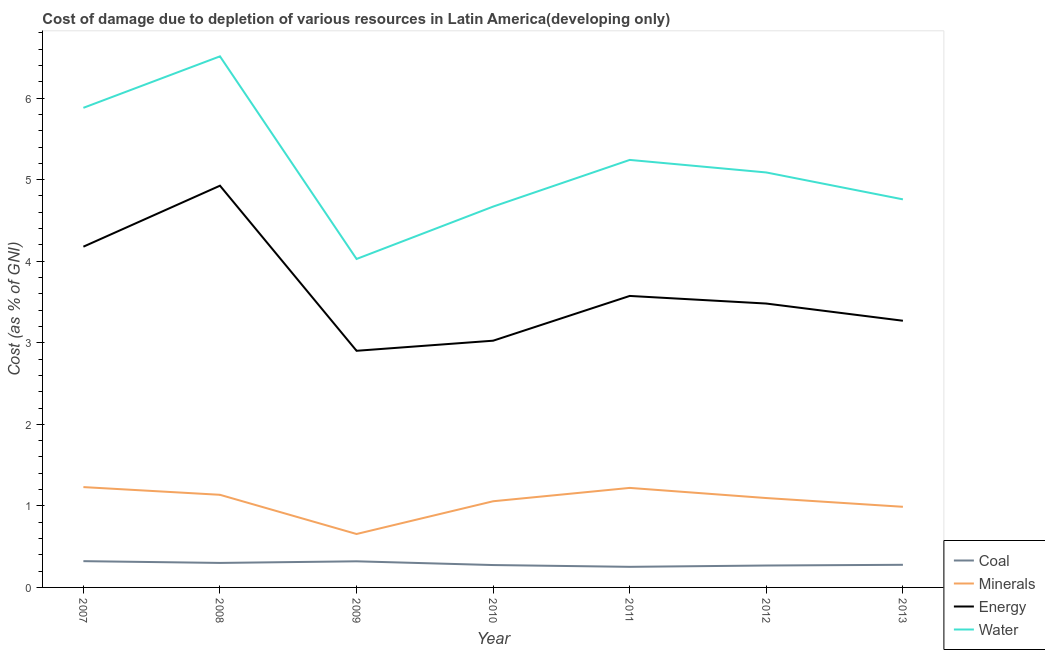Does the line corresponding to cost of damage due to depletion of energy intersect with the line corresponding to cost of damage due to depletion of minerals?
Your answer should be very brief. No. What is the cost of damage due to depletion of coal in 2012?
Your answer should be compact. 0.27. Across all years, what is the maximum cost of damage due to depletion of water?
Your answer should be very brief. 6.51. Across all years, what is the minimum cost of damage due to depletion of water?
Keep it short and to the point. 4.03. In which year was the cost of damage due to depletion of minerals minimum?
Make the answer very short. 2009. What is the total cost of damage due to depletion of minerals in the graph?
Provide a succinct answer. 7.38. What is the difference between the cost of damage due to depletion of energy in 2008 and that in 2011?
Give a very brief answer. 1.35. What is the difference between the cost of damage due to depletion of coal in 2011 and the cost of damage due to depletion of water in 2012?
Keep it short and to the point. -4.84. What is the average cost of damage due to depletion of water per year?
Offer a terse response. 5.17. In the year 2011, what is the difference between the cost of damage due to depletion of coal and cost of damage due to depletion of energy?
Your response must be concise. -3.32. What is the ratio of the cost of damage due to depletion of energy in 2010 to that in 2011?
Your answer should be compact. 0.85. Is the cost of damage due to depletion of coal in 2010 less than that in 2012?
Give a very brief answer. No. What is the difference between the highest and the second highest cost of damage due to depletion of water?
Ensure brevity in your answer.  0.63. What is the difference between the highest and the lowest cost of damage due to depletion of minerals?
Provide a succinct answer. 0.58. In how many years, is the cost of damage due to depletion of minerals greater than the average cost of damage due to depletion of minerals taken over all years?
Your answer should be compact. 5. Is the sum of the cost of damage due to depletion of water in 2011 and 2013 greater than the maximum cost of damage due to depletion of energy across all years?
Ensure brevity in your answer.  Yes. Does the cost of damage due to depletion of energy monotonically increase over the years?
Give a very brief answer. No. How many years are there in the graph?
Make the answer very short. 7. What is the difference between two consecutive major ticks on the Y-axis?
Offer a very short reply. 1. Where does the legend appear in the graph?
Offer a very short reply. Bottom right. How many legend labels are there?
Make the answer very short. 4. What is the title of the graph?
Offer a very short reply. Cost of damage due to depletion of various resources in Latin America(developing only) . Does "UNRWA" appear as one of the legend labels in the graph?
Your answer should be compact. No. What is the label or title of the X-axis?
Your answer should be very brief. Year. What is the label or title of the Y-axis?
Keep it short and to the point. Cost (as % of GNI). What is the Cost (as % of GNI) in Coal in 2007?
Offer a terse response. 0.32. What is the Cost (as % of GNI) of Minerals in 2007?
Provide a short and direct response. 1.23. What is the Cost (as % of GNI) in Energy in 2007?
Ensure brevity in your answer.  4.18. What is the Cost (as % of GNI) of Water in 2007?
Keep it short and to the point. 5.88. What is the Cost (as % of GNI) of Coal in 2008?
Make the answer very short. 0.3. What is the Cost (as % of GNI) of Minerals in 2008?
Offer a very short reply. 1.14. What is the Cost (as % of GNI) in Energy in 2008?
Your answer should be very brief. 4.93. What is the Cost (as % of GNI) in Water in 2008?
Make the answer very short. 6.51. What is the Cost (as % of GNI) in Coal in 2009?
Provide a short and direct response. 0.32. What is the Cost (as % of GNI) of Minerals in 2009?
Your response must be concise. 0.66. What is the Cost (as % of GNI) of Energy in 2009?
Provide a succinct answer. 2.9. What is the Cost (as % of GNI) in Water in 2009?
Offer a very short reply. 4.03. What is the Cost (as % of GNI) in Coal in 2010?
Your answer should be compact. 0.27. What is the Cost (as % of GNI) of Minerals in 2010?
Provide a succinct answer. 1.06. What is the Cost (as % of GNI) in Energy in 2010?
Provide a short and direct response. 3.03. What is the Cost (as % of GNI) of Water in 2010?
Give a very brief answer. 4.67. What is the Cost (as % of GNI) in Coal in 2011?
Give a very brief answer. 0.25. What is the Cost (as % of GNI) of Minerals in 2011?
Provide a succinct answer. 1.22. What is the Cost (as % of GNI) in Energy in 2011?
Provide a succinct answer. 3.57. What is the Cost (as % of GNI) in Water in 2011?
Your response must be concise. 5.24. What is the Cost (as % of GNI) in Coal in 2012?
Keep it short and to the point. 0.27. What is the Cost (as % of GNI) of Minerals in 2012?
Your answer should be very brief. 1.1. What is the Cost (as % of GNI) of Energy in 2012?
Provide a succinct answer. 3.48. What is the Cost (as % of GNI) in Water in 2012?
Offer a very short reply. 5.09. What is the Cost (as % of GNI) in Coal in 2013?
Your answer should be very brief. 0.28. What is the Cost (as % of GNI) in Minerals in 2013?
Make the answer very short. 0.99. What is the Cost (as % of GNI) of Energy in 2013?
Ensure brevity in your answer.  3.27. What is the Cost (as % of GNI) in Water in 2013?
Keep it short and to the point. 4.76. Across all years, what is the maximum Cost (as % of GNI) in Coal?
Keep it short and to the point. 0.32. Across all years, what is the maximum Cost (as % of GNI) of Minerals?
Ensure brevity in your answer.  1.23. Across all years, what is the maximum Cost (as % of GNI) of Energy?
Your response must be concise. 4.93. Across all years, what is the maximum Cost (as % of GNI) of Water?
Keep it short and to the point. 6.51. Across all years, what is the minimum Cost (as % of GNI) in Coal?
Give a very brief answer. 0.25. Across all years, what is the minimum Cost (as % of GNI) of Minerals?
Your response must be concise. 0.66. Across all years, what is the minimum Cost (as % of GNI) of Energy?
Make the answer very short. 2.9. Across all years, what is the minimum Cost (as % of GNI) in Water?
Offer a very short reply. 4.03. What is the total Cost (as % of GNI) in Coal in the graph?
Your answer should be very brief. 2.02. What is the total Cost (as % of GNI) of Minerals in the graph?
Your answer should be compact. 7.38. What is the total Cost (as % of GNI) in Energy in the graph?
Your response must be concise. 25.36. What is the total Cost (as % of GNI) in Water in the graph?
Provide a succinct answer. 36.18. What is the difference between the Cost (as % of GNI) in Coal in 2007 and that in 2008?
Offer a terse response. 0.02. What is the difference between the Cost (as % of GNI) of Minerals in 2007 and that in 2008?
Provide a short and direct response. 0.09. What is the difference between the Cost (as % of GNI) of Energy in 2007 and that in 2008?
Your response must be concise. -0.75. What is the difference between the Cost (as % of GNI) of Water in 2007 and that in 2008?
Offer a very short reply. -0.63. What is the difference between the Cost (as % of GNI) in Coal in 2007 and that in 2009?
Provide a short and direct response. 0. What is the difference between the Cost (as % of GNI) in Minerals in 2007 and that in 2009?
Provide a succinct answer. 0.58. What is the difference between the Cost (as % of GNI) of Energy in 2007 and that in 2009?
Make the answer very short. 1.28. What is the difference between the Cost (as % of GNI) in Water in 2007 and that in 2009?
Make the answer very short. 1.85. What is the difference between the Cost (as % of GNI) of Coal in 2007 and that in 2010?
Offer a terse response. 0.05. What is the difference between the Cost (as % of GNI) of Minerals in 2007 and that in 2010?
Keep it short and to the point. 0.17. What is the difference between the Cost (as % of GNI) of Energy in 2007 and that in 2010?
Provide a short and direct response. 1.15. What is the difference between the Cost (as % of GNI) in Water in 2007 and that in 2010?
Ensure brevity in your answer.  1.21. What is the difference between the Cost (as % of GNI) in Coal in 2007 and that in 2011?
Provide a short and direct response. 0.07. What is the difference between the Cost (as % of GNI) in Minerals in 2007 and that in 2011?
Your response must be concise. 0.01. What is the difference between the Cost (as % of GNI) in Energy in 2007 and that in 2011?
Offer a terse response. 0.6. What is the difference between the Cost (as % of GNI) in Water in 2007 and that in 2011?
Provide a short and direct response. 0.64. What is the difference between the Cost (as % of GNI) in Coal in 2007 and that in 2012?
Keep it short and to the point. 0.05. What is the difference between the Cost (as % of GNI) of Minerals in 2007 and that in 2012?
Provide a short and direct response. 0.13. What is the difference between the Cost (as % of GNI) in Energy in 2007 and that in 2012?
Give a very brief answer. 0.7. What is the difference between the Cost (as % of GNI) of Water in 2007 and that in 2012?
Offer a terse response. 0.79. What is the difference between the Cost (as % of GNI) of Coal in 2007 and that in 2013?
Your answer should be compact. 0.04. What is the difference between the Cost (as % of GNI) of Minerals in 2007 and that in 2013?
Your answer should be compact. 0.24. What is the difference between the Cost (as % of GNI) of Energy in 2007 and that in 2013?
Ensure brevity in your answer.  0.91. What is the difference between the Cost (as % of GNI) of Water in 2007 and that in 2013?
Make the answer very short. 1.12. What is the difference between the Cost (as % of GNI) of Coal in 2008 and that in 2009?
Make the answer very short. -0.02. What is the difference between the Cost (as % of GNI) of Minerals in 2008 and that in 2009?
Your answer should be very brief. 0.48. What is the difference between the Cost (as % of GNI) in Energy in 2008 and that in 2009?
Provide a succinct answer. 2.02. What is the difference between the Cost (as % of GNI) of Water in 2008 and that in 2009?
Your response must be concise. 2.48. What is the difference between the Cost (as % of GNI) of Coal in 2008 and that in 2010?
Keep it short and to the point. 0.03. What is the difference between the Cost (as % of GNI) of Minerals in 2008 and that in 2010?
Make the answer very short. 0.08. What is the difference between the Cost (as % of GNI) of Energy in 2008 and that in 2010?
Provide a short and direct response. 1.9. What is the difference between the Cost (as % of GNI) in Water in 2008 and that in 2010?
Offer a very short reply. 1.84. What is the difference between the Cost (as % of GNI) of Coal in 2008 and that in 2011?
Give a very brief answer. 0.05. What is the difference between the Cost (as % of GNI) of Minerals in 2008 and that in 2011?
Provide a succinct answer. -0.08. What is the difference between the Cost (as % of GNI) in Energy in 2008 and that in 2011?
Ensure brevity in your answer.  1.35. What is the difference between the Cost (as % of GNI) of Water in 2008 and that in 2011?
Keep it short and to the point. 1.27. What is the difference between the Cost (as % of GNI) in Coal in 2008 and that in 2012?
Offer a terse response. 0.03. What is the difference between the Cost (as % of GNI) of Minerals in 2008 and that in 2012?
Keep it short and to the point. 0.04. What is the difference between the Cost (as % of GNI) of Energy in 2008 and that in 2012?
Make the answer very short. 1.45. What is the difference between the Cost (as % of GNI) in Water in 2008 and that in 2012?
Your response must be concise. 1.42. What is the difference between the Cost (as % of GNI) in Coal in 2008 and that in 2013?
Provide a short and direct response. 0.02. What is the difference between the Cost (as % of GNI) in Minerals in 2008 and that in 2013?
Give a very brief answer. 0.15. What is the difference between the Cost (as % of GNI) of Energy in 2008 and that in 2013?
Offer a terse response. 1.66. What is the difference between the Cost (as % of GNI) of Water in 2008 and that in 2013?
Provide a short and direct response. 1.75. What is the difference between the Cost (as % of GNI) of Coal in 2009 and that in 2010?
Provide a short and direct response. 0.05. What is the difference between the Cost (as % of GNI) in Minerals in 2009 and that in 2010?
Provide a succinct answer. -0.4. What is the difference between the Cost (as % of GNI) in Energy in 2009 and that in 2010?
Ensure brevity in your answer.  -0.12. What is the difference between the Cost (as % of GNI) in Water in 2009 and that in 2010?
Your response must be concise. -0.64. What is the difference between the Cost (as % of GNI) of Coal in 2009 and that in 2011?
Provide a succinct answer. 0.07. What is the difference between the Cost (as % of GNI) in Minerals in 2009 and that in 2011?
Provide a short and direct response. -0.57. What is the difference between the Cost (as % of GNI) in Energy in 2009 and that in 2011?
Your answer should be very brief. -0.67. What is the difference between the Cost (as % of GNI) in Water in 2009 and that in 2011?
Make the answer very short. -1.21. What is the difference between the Cost (as % of GNI) in Coal in 2009 and that in 2012?
Provide a succinct answer. 0.05. What is the difference between the Cost (as % of GNI) of Minerals in 2009 and that in 2012?
Keep it short and to the point. -0.44. What is the difference between the Cost (as % of GNI) of Energy in 2009 and that in 2012?
Give a very brief answer. -0.58. What is the difference between the Cost (as % of GNI) of Water in 2009 and that in 2012?
Keep it short and to the point. -1.06. What is the difference between the Cost (as % of GNI) in Coal in 2009 and that in 2013?
Make the answer very short. 0.04. What is the difference between the Cost (as % of GNI) in Minerals in 2009 and that in 2013?
Keep it short and to the point. -0.33. What is the difference between the Cost (as % of GNI) in Energy in 2009 and that in 2013?
Give a very brief answer. -0.37. What is the difference between the Cost (as % of GNI) in Water in 2009 and that in 2013?
Ensure brevity in your answer.  -0.73. What is the difference between the Cost (as % of GNI) in Coal in 2010 and that in 2011?
Ensure brevity in your answer.  0.02. What is the difference between the Cost (as % of GNI) in Minerals in 2010 and that in 2011?
Make the answer very short. -0.16. What is the difference between the Cost (as % of GNI) of Energy in 2010 and that in 2011?
Provide a succinct answer. -0.55. What is the difference between the Cost (as % of GNI) in Water in 2010 and that in 2011?
Provide a short and direct response. -0.57. What is the difference between the Cost (as % of GNI) of Coal in 2010 and that in 2012?
Ensure brevity in your answer.  0.01. What is the difference between the Cost (as % of GNI) in Minerals in 2010 and that in 2012?
Offer a terse response. -0.04. What is the difference between the Cost (as % of GNI) in Energy in 2010 and that in 2012?
Your answer should be very brief. -0.46. What is the difference between the Cost (as % of GNI) of Water in 2010 and that in 2012?
Your answer should be very brief. -0.42. What is the difference between the Cost (as % of GNI) in Coal in 2010 and that in 2013?
Your answer should be compact. -0. What is the difference between the Cost (as % of GNI) in Minerals in 2010 and that in 2013?
Provide a short and direct response. 0.07. What is the difference between the Cost (as % of GNI) of Energy in 2010 and that in 2013?
Offer a very short reply. -0.24. What is the difference between the Cost (as % of GNI) of Water in 2010 and that in 2013?
Offer a very short reply. -0.09. What is the difference between the Cost (as % of GNI) in Coal in 2011 and that in 2012?
Your answer should be compact. -0.02. What is the difference between the Cost (as % of GNI) of Minerals in 2011 and that in 2012?
Offer a very short reply. 0.12. What is the difference between the Cost (as % of GNI) of Energy in 2011 and that in 2012?
Provide a short and direct response. 0.09. What is the difference between the Cost (as % of GNI) of Water in 2011 and that in 2012?
Offer a very short reply. 0.15. What is the difference between the Cost (as % of GNI) in Coal in 2011 and that in 2013?
Your answer should be compact. -0.03. What is the difference between the Cost (as % of GNI) in Minerals in 2011 and that in 2013?
Your response must be concise. 0.23. What is the difference between the Cost (as % of GNI) in Energy in 2011 and that in 2013?
Offer a terse response. 0.3. What is the difference between the Cost (as % of GNI) in Water in 2011 and that in 2013?
Provide a short and direct response. 0.48. What is the difference between the Cost (as % of GNI) of Coal in 2012 and that in 2013?
Offer a very short reply. -0.01. What is the difference between the Cost (as % of GNI) of Minerals in 2012 and that in 2013?
Your answer should be compact. 0.11. What is the difference between the Cost (as % of GNI) of Energy in 2012 and that in 2013?
Give a very brief answer. 0.21. What is the difference between the Cost (as % of GNI) of Water in 2012 and that in 2013?
Give a very brief answer. 0.33. What is the difference between the Cost (as % of GNI) in Coal in 2007 and the Cost (as % of GNI) in Minerals in 2008?
Make the answer very short. -0.81. What is the difference between the Cost (as % of GNI) of Coal in 2007 and the Cost (as % of GNI) of Energy in 2008?
Offer a very short reply. -4.6. What is the difference between the Cost (as % of GNI) of Coal in 2007 and the Cost (as % of GNI) of Water in 2008?
Offer a terse response. -6.19. What is the difference between the Cost (as % of GNI) of Minerals in 2007 and the Cost (as % of GNI) of Energy in 2008?
Offer a very short reply. -3.7. What is the difference between the Cost (as % of GNI) of Minerals in 2007 and the Cost (as % of GNI) of Water in 2008?
Your answer should be compact. -5.28. What is the difference between the Cost (as % of GNI) of Energy in 2007 and the Cost (as % of GNI) of Water in 2008?
Offer a very short reply. -2.33. What is the difference between the Cost (as % of GNI) in Coal in 2007 and the Cost (as % of GNI) in Minerals in 2009?
Your answer should be very brief. -0.33. What is the difference between the Cost (as % of GNI) of Coal in 2007 and the Cost (as % of GNI) of Energy in 2009?
Keep it short and to the point. -2.58. What is the difference between the Cost (as % of GNI) in Coal in 2007 and the Cost (as % of GNI) in Water in 2009?
Your response must be concise. -3.71. What is the difference between the Cost (as % of GNI) of Minerals in 2007 and the Cost (as % of GNI) of Energy in 2009?
Offer a terse response. -1.67. What is the difference between the Cost (as % of GNI) in Minerals in 2007 and the Cost (as % of GNI) in Water in 2009?
Your answer should be very brief. -2.8. What is the difference between the Cost (as % of GNI) of Energy in 2007 and the Cost (as % of GNI) of Water in 2009?
Provide a succinct answer. 0.15. What is the difference between the Cost (as % of GNI) of Coal in 2007 and the Cost (as % of GNI) of Minerals in 2010?
Give a very brief answer. -0.73. What is the difference between the Cost (as % of GNI) of Coal in 2007 and the Cost (as % of GNI) of Energy in 2010?
Your answer should be very brief. -2.7. What is the difference between the Cost (as % of GNI) of Coal in 2007 and the Cost (as % of GNI) of Water in 2010?
Provide a succinct answer. -4.35. What is the difference between the Cost (as % of GNI) in Minerals in 2007 and the Cost (as % of GNI) in Energy in 2010?
Provide a succinct answer. -1.8. What is the difference between the Cost (as % of GNI) in Minerals in 2007 and the Cost (as % of GNI) in Water in 2010?
Provide a short and direct response. -3.44. What is the difference between the Cost (as % of GNI) of Energy in 2007 and the Cost (as % of GNI) of Water in 2010?
Your answer should be compact. -0.49. What is the difference between the Cost (as % of GNI) of Coal in 2007 and the Cost (as % of GNI) of Minerals in 2011?
Make the answer very short. -0.9. What is the difference between the Cost (as % of GNI) of Coal in 2007 and the Cost (as % of GNI) of Energy in 2011?
Keep it short and to the point. -3.25. What is the difference between the Cost (as % of GNI) in Coal in 2007 and the Cost (as % of GNI) in Water in 2011?
Offer a terse response. -4.92. What is the difference between the Cost (as % of GNI) in Minerals in 2007 and the Cost (as % of GNI) in Energy in 2011?
Your response must be concise. -2.34. What is the difference between the Cost (as % of GNI) of Minerals in 2007 and the Cost (as % of GNI) of Water in 2011?
Offer a terse response. -4.01. What is the difference between the Cost (as % of GNI) in Energy in 2007 and the Cost (as % of GNI) in Water in 2011?
Make the answer very short. -1.06. What is the difference between the Cost (as % of GNI) of Coal in 2007 and the Cost (as % of GNI) of Minerals in 2012?
Give a very brief answer. -0.77. What is the difference between the Cost (as % of GNI) of Coal in 2007 and the Cost (as % of GNI) of Energy in 2012?
Offer a very short reply. -3.16. What is the difference between the Cost (as % of GNI) in Coal in 2007 and the Cost (as % of GNI) in Water in 2012?
Provide a succinct answer. -4.77. What is the difference between the Cost (as % of GNI) in Minerals in 2007 and the Cost (as % of GNI) in Energy in 2012?
Offer a very short reply. -2.25. What is the difference between the Cost (as % of GNI) in Minerals in 2007 and the Cost (as % of GNI) in Water in 2012?
Ensure brevity in your answer.  -3.86. What is the difference between the Cost (as % of GNI) of Energy in 2007 and the Cost (as % of GNI) of Water in 2012?
Offer a terse response. -0.91. What is the difference between the Cost (as % of GNI) in Coal in 2007 and the Cost (as % of GNI) in Minerals in 2013?
Ensure brevity in your answer.  -0.67. What is the difference between the Cost (as % of GNI) in Coal in 2007 and the Cost (as % of GNI) in Energy in 2013?
Provide a succinct answer. -2.95. What is the difference between the Cost (as % of GNI) of Coal in 2007 and the Cost (as % of GNI) of Water in 2013?
Ensure brevity in your answer.  -4.44. What is the difference between the Cost (as % of GNI) in Minerals in 2007 and the Cost (as % of GNI) in Energy in 2013?
Provide a succinct answer. -2.04. What is the difference between the Cost (as % of GNI) in Minerals in 2007 and the Cost (as % of GNI) in Water in 2013?
Your answer should be compact. -3.53. What is the difference between the Cost (as % of GNI) in Energy in 2007 and the Cost (as % of GNI) in Water in 2013?
Provide a succinct answer. -0.58. What is the difference between the Cost (as % of GNI) in Coal in 2008 and the Cost (as % of GNI) in Minerals in 2009?
Ensure brevity in your answer.  -0.35. What is the difference between the Cost (as % of GNI) of Coal in 2008 and the Cost (as % of GNI) of Energy in 2009?
Provide a succinct answer. -2.6. What is the difference between the Cost (as % of GNI) of Coal in 2008 and the Cost (as % of GNI) of Water in 2009?
Make the answer very short. -3.73. What is the difference between the Cost (as % of GNI) of Minerals in 2008 and the Cost (as % of GNI) of Energy in 2009?
Ensure brevity in your answer.  -1.77. What is the difference between the Cost (as % of GNI) of Minerals in 2008 and the Cost (as % of GNI) of Water in 2009?
Provide a short and direct response. -2.89. What is the difference between the Cost (as % of GNI) in Energy in 2008 and the Cost (as % of GNI) in Water in 2009?
Your answer should be very brief. 0.9. What is the difference between the Cost (as % of GNI) in Coal in 2008 and the Cost (as % of GNI) in Minerals in 2010?
Provide a short and direct response. -0.76. What is the difference between the Cost (as % of GNI) in Coal in 2008 and the Cost (as % of GNI) in Energy in 2010?
Ensure brevity in your answer.  -2.73. What is the difference between the Cost (as % of GNI) in Coal in 2008 and the Cost (as % of GNI) in Water in 2010?
Offer a very short reply. -4.37. What is the difference between the Cost (as % of GNI) in Minerals in 2008 and the Cost (as % of GNI) in Energy in 2010?
Make the answer very short. -1.89. What is the difference between the Cost (as % of GNI) in Minerals in 2008 and the Cost (as % of GNI) in Water in 2010?
Offer a terse response. -3.53. What is the difference between the Cost (as % of GNI) of Energy in 2008 and the Cost (as % of GNI) of Water in 2010?
Offer a terse response. 0.26. What is the difference between the Cost (as % of GNI) of Coal in 2008 and the Cost (as % of GNI) of Minerals in 2011?
Give a very brief answer. -0.92. What is the difference between the Cost (as % of GNI) of Coal in 2008 and the Cost (as % of GNI) of Energy in 2011?
Keep it short and to the point. -3.27. What is the difference between the Cost (as % of GNI) of Coal in 2008 and the Cost (as % of GNI) of Water in 2011?
Give a very brief answer. -4.94. What is the difference between the Cost (as % of GNI) of Minerals in 2008 and the Cost (as % of GNI) of Energy in 2011?
Ensure brevity in your answer.  -2.44. What is the difference between the Cost (as % of GNI) in Minerals in 2008 and the Cost (as % of GNI) in Water in 2011?
Provide a short and direct response. -4.11. What is the difference between the Cost (as % of GNI) of Energy in 2008 and the Cost (as % of GNI) of Water in 2011?
Offer a terse response. -0.32. What is the difference between the Cost (as % of GNI) of Coal in 2008 and the Cost (as % of GNI) of Minerals in 2012?
Your response must be concise. -0.8. What is the difference between the Cost (as % of GNI) of Coal in 2008 and the Cost (as % of GNI) of Energy in 2012?
Your response must be concise. -3.18. What is the difference between the Cost (as % of GNI) of Coal in 2008 and the Cost (as % of GNI) of Water in 2012?
Provide a short and direct response. -4.79. What is the difference between the Cost (as % of GNI) in Minerals in 2008 and the Cost (as % of GNI) in Energy in 2012?
Offer a very short reply. -2.35. What is the difference between the Cost (as % of GNI) of Minerals in 2008 and the Cost (as % of GNI) of Water in 2012?
Keep it short and to the point. -3.95. What is the difference between the Cost (as % of GNI) in Energy in 2008 and the Cost (as % of GNI) in Water in 2012?
Offer a terse response. -0.16. What is the difference between the Cost (as % of GNI) of Coal in 2008 and the Cost (as % of GNI) of Minerals in 2013?
Offer a terse response. -0.69. What is the difference between the Cost (as % of GNI) of Coal in 2008 and the Cost (as % of GNI) of Energy in 2013?
Offer a terse response. -2.97. What is the difference between the Cost (as % of GNI) of Coal in 2008 and the Cost (as % of GNI) of Water in 2013?
Give a very brief answer. -4.46. What is the difference between the Cost (as % of GNI) of Minerals in 2008 and the Cost (as % of GNI) of Energy in 2013?
Keep it short and to the point. -2.13. What is the difference between the Cost (as % of GNI) in Minerals in 2008 and the Cost (as % of GNI) in Water in 2013?
Offer a very short reply. -3.62. What is the difference between the Cost (as % of GNI) in Energy in 2008 and the Cost (as % of GNI) in Water in 2013?
Offer a terse response. 0.17. What is the difference between the Cost (as % of GNI) of Coal in 2009 and the Cost (as % of GNI) of Minerals in 2010?
Keep it short and to the point. -0.74. What is the difference between the Cost (as % of GNI) of Coal in 2009 and the Cost (as % of GNI) of Energy in 2010?
Give a very brief answer. -2.71. What is the difference between the Cost (as % of GNI) of Coal in 2009 and the Cost (as % of GNI) of Water in 2010?
Your answer should be compact. -4.35. What is the difference between the Cost (as % of GNI) in Minerals in 2009 and the Cost (as % of GNI) in Energy in 2010?
Offer a terse response. -2.37. What is the difference between the Cost (as % of GNI) in Minerals in 2009 and the Cost (as % of GNI) in Water in 2010?
Give a very brief answer. -4.01. What is the difference between the Cost (as % of GNI) of Energy in 2009 and the Cost (as % of GNI) of Water in 2010?
Make the answer very short. -1.77. What is the difference between the Cost (as % of GNI) of Coal in 2009 and the Cost (as % of GNI) of Minerals in 2011?
Give a very brief answer. -0.9. What is the difference between the Cost (as % of GNI) in Coal in 2009 and the Cost (as % of GNI) in Energy in 2011?
Provide a short and direct response. -3.25. What is the difference between the Cost (as % of GNI) in Coal in 2009 and the Cost (as % of GNI) in Water in 2011?
Provide a succinct answer. -4.92. What is the difference between the Cost (as % of GNI) of Minerals in 2009 and the Cost (as % of GNI) of Energy in 2011?
Provide a succinct answer. -2.92. What is the difference between the Cost (as % of GNI) in Minerals in 2009 and the Cost (as % of GNI) in Water in 2011?
Keep it short and to the point. -4.59. What is the difference between the Cost (as % of GNI) of Energy in 2009 and the Cost (as % of GNI) of Water in 2011?
Your answer should be compact. -2.34. What is the difference between the Cost (as % of GNI) in Coal in 2009 and the Cost (as % of GNI) in Minerals in 2012?
Offer a very short reply. -0.78. What is the difference between the Cost (as % of GNI) of Coal in 2009 and the Cost (as % of GNI) of Energy in 2012?
Make the answer very short. -3.16. What is the difference between the Cost (as % of GNI) in Coal in 2009 and the Cost (as % of GNI) in Water in 2012?
Your answer should be very brief. -4.77. What is the difference between the Cost (as % of GNI) of Minerals in 2009 and the Cost (as % of GNI) of Energy in 2012?
Offer a very short reply. -2.83. What is the difference between the Cost (as % of GNI) of Minerals in 2009 and the Cost (as % of GNI) of Water in 2012?
Make the answer very short. -4.43. What is the difference between the Cost (as % of GNI) of Energy in 2009 and the Cost (as % of GNI) of Water in 2012?
Offer a terse response. -2.19. What is the difference between the Cost (as % of GNI) in Coal in 2009 and the Cost (as % of GNI) in Minerals in 2013?
Provide a short and direct response. -0.67. What is the difference between the Cost (as % of GNI) of Coal in 2009 and the Cost (as % of GNI) of Energy in 2013?
Offer a very short reply. -2.95. What is the difference between the Cost (as % of GNI) of Coal in 2009 and the Cost (as % of GNI) of Water in 2013?
Keep it short and to the point. -4.44. What is the difference between the Cost (as % of GNI) in Minerals in 2009 and the Cost (as % of GNI) in Energy in 2013?
Keep it short and to the point. -2.62. What is the difference between the Cost (as % of GNI) of Minerals in 2009 and the Cost (as % of GNI) of Water in 2013?
Ensure brevity in your answer.  -4.1. What is the difference between the Cost (as % of GNI) of Energy in 2009 and the Cost (as % of GNI) of Water in 2013?
Your answer should be compact. -1.86. What is the difference between the Cost (as % of GNI) of Coal in 2010 and the Cost (as % of GNI) of Minerals in 2011?
Offer a terse response. -0.95. What is the difference between the Cost (as % of GNI) in Coal in 2010 and the Cost (as % of GNI) in Energy in 2011?
Your answer should be very brief. -3.3. What is the difference between the Cost (as % of GNI) in Coal in 2010 and the Cost (as % of GNI) in Water in 2011?
Your response must be concise. -4.97. What is the difference between the Cost (as % of GNI) in Minerals in 2010 and the Cost (as % of GNI) in Energy in 2011?
Provide a short and direct response. -2.52. What is the difference between the Cost (as % of GNI) in Minerals in 2010 and the Cost (as % of GNI) in Water in 2011?
Provide a short and direct response. -4.19. What is the difference between the Cost (as % of GNI) of Energy in 2010 and the Cost (as % of GNI) of Water in 2011?
Make the answer very short. -2.22. What is the difference between the Cost (as % of GNI) in Coal in 2010 and the Cost (as % of GNI) in Minerals in 2012?
Give a very brief answer. -0.82. What is the difference between the Cost (as % of GNI) of Coal in 2010 and the Cost (as % of GNI) of Energy in 2012?
Ensure brevity in your answer.  -3.21. What is the difference between the Cost (as % of GNI) of Coal in 2010 and the Cost (as % of GNI) of Water in 2012?
Provide a short and direct response. -4.81. What is the difference between the Cost (as % of GNI) in Minerals in 2010 and the Cost (as % of GNI) in Energy in 2012?
Give a very brief answer. -2.42. What is the difference between the Cost (as % of GNI) in Minerals in 2010 and the Cost (as % of GNI) in Water in 2012?
Your response must be concise. -4.03. What is the difference between the Cost (as % of GNI) in Energy in 2010 and the Cost (as % of GNI) in Water in 2012?
Give a very brief answer. -2.06. What is the difference between the Cost (as % of GNI) of Coal in 2010 and the Cost (as % of GNI) of Minerals in 2013?
Ensure brevity in your answer.  -0.71. What is the difference between the Cost (as % of GNI) in Coal in 2010 and the Cost (as % of GNI) in Energy in 2013?
Give a very brief answer. -3. What is the difference between the Cost (as % of GNI) of Coal in 2010 and the Cost (as % of GNI) of Water in 2013?
Your response must be concise. -4.48. What is the difference between the Cost (as % of GNI) of Minerals in 2010 and the Cost (as % of GNI) of Energy in 2013?
Offer a terse response. -2.21. What is the difference between the Cost (as % of GNI) in Minerals in 2010 and the Cost (as % of GNI) in Water in 2013?
Make the answer very short. -3.7. What is the difference between the Cost (as % of GNI) of Energy in 2010 and the Cost (as % of GNI) of Water in 2013?
Offer a very short reply. -1.73. What is the difference between the Cost (as % of GNI) in Coal in 2011 and the Cost (as % of GNI) in Minerals in 2012?
Offer a very short reply. -0.84. What is the difference between the Cost (as % of GNI) of Coal in 2011 and the Cost (as % of GNI) of Energy in 2012?
Give a very brief answer. -3.23. What is the difference between the Cost (as % of GNI) of Coal in 2011 and the Cost (as % of GNI) of Water in 2012?
Your response must be concise. -4.84. What is the difference between the Cost (as % of GNI) in Minerals in 2011 and the Cost (as % of GNI) in Energy in 2012?
Keep it short and to the point. -2.26. What is the difference between the Cost (as % of GNI) in Minerals in 2011 and the Cost (as % of GNI) in Water in 2012?
Make the answer very short. -3.87. What is the difference between the Cost (as % of GNI) of Energy in 2011 and the Cost (as % of GNI) of Water in 2012?
Make the answer very short. -1.51. What is the difference between the Cost (as % of GNI) of Coal in 2011 and the Cost (as % of GNI) of Minerals in 2013?
Offer a terse response. -0.74. What is the difference between the Cost (as % of GNI) in Coal in 2011 and the Cost (as % of GNI) in Energy in 2013?
Ensure brevity in your answer.  -3.02. What is the difference between the Cost (as % of GNI) of Coal in 2011 and the Cost (as % of GNI) of Water in 2013?
Your response must be concise. -4.51. What is the difference between the Cost (as % of GNI) of Minerals in 2011 and the Cost (as % of GNI) of Energy in 2013?
Provide a succinct answer. -2.05. What is the difference between the Cost (as % of GNI) of Minerals in 2011 and the Cost (as % of GNI) of Water in 2013?
Give a very brief answer. -3.54. What is the difference between the Cost (as % of GNI) in Energy in 2011 and the Cost (as % of GNI) in Water in 2013?
Your answer should be very brief. -1.18. What is the difference between the Cost (as % of GNI) of Coal in 2012 and the Cost (as % of GNI) of Minerals in 2013?
Provide a short and direct response. -0.72. What is the difference between the Cost (as % of GNI) in Coal in 2012 and the Cost (as % of GNI) in Energy in 2013?
Your answer should be compact. -3. What is the difference between the Cost (as % of GNI) in Coal in 2012 and the Cost (as % of GNI) in Water in 2013?
Provide a succinct answer. -4.49. What is the difference between the Cost (as % of GNI) in Minerals in 2012 and the Cost (as % of GNI) in Energy in 2013?
Give a very brief answer. -2.17. What is the difference between the Cost (as % of GNI) in Minerals in 2012 and the Cost (as % of GNI) in Water in 2013?
Give a very brief answer. -3.66. What is the difference between the Cost (as % of GNI) in Energy in 2012 and the Cost (as % of GNI) in Water in 2013?
Offer a terse response. -1.28. What is the average Cost (as % of GNI) of Coal per year?
Your answer should be compact. 0.29. What is the average Cost (as % of GNI) in Minerals per year?
Your answer should be compact. 1.05. What is the average Cost (as % of GNI) in Energy per year?
Provide a succinct answer. 3.62. What is the average Cost (as % of GNI) of Water per year?
Offer a terse response. 5.17. In the year 2007, what is the difference between the Cost (as % of GNI) of Coal and Cost (as % of GNI) of Minerals?
Provide a succinct answer. -0.91. In the year 2007, what is the difference between the Cost (as % of GNI) in Coal and Cost (as % of GNI) in Energy?
Provide a succinct answer. -3.86. In the year 2007, what is the difference between the Cost (as % of GNI) in Coal and Cost (as % of GNI) in Water?
Give a very brief answer. -5.56. In the year 2007, what is the difference between the Cost (as % of GNI) in Minerals and Cost (as % of GNI) in Energy?
Offer a terse response. -2.95. In the year 2007, what is the difference between the Cost (as % of GNI) in Minerals and Cost (as % of GNI) in Water?
Provide a short and direct response. -4.65. In the year 2007, what is the difference between the Cost (as % of GNI) of Energy and Cost (as % of GNI) of Water?
Provide a succinct answer. -1.7. In the year 2008, what is the difference between the Cost (as % of GNI) of Coal and Cost (as % of GNI) of Minerals?
Your response must be concise. -0.84. In the year 2008, what is the difference between the Cost (as % of GNI) in Coal and Cost (as % of GNI) in Energy?
Make the answer very short. -4.63. In the year 2008, what is the difference between the Cost (as % of GNI) in Coal and Cost (as % of GNI) in Water?
Your answer should be very brief. -6.21. In the year 2008, what is the difference between the Cost (as % of GNI) in Minerals and Cost (as % of GNI) in Energy?
Ensure brevity in your answer.  -3.79. In the year 2008, what is the difference between the Cost (as % of GNI) in Minerals and Cost (as % of GNI) in Water?
Keep it short and to the point. -5.38. In the year 2008, what is the difference between the Cost (as % of GNI) of Energy and Cost (as % of GNI) of Water?
Your answer should be compact. -1.59. In the year 2009, what is the difference between the Cost (as % of GNI) in Coal and Cost (as % of GNI) in Minerals?
Give a very brief answer. -0.33. In the year 2009, what is the difference between the Cost (as % of GNI) in Coal and Cost (as % of GNI) in Energy?
Your answer should be compact. -2.58. In the year 2009, what is the difference between the Cost (as % of GNI) of Coal and Cost (as % of GNI) of Water?
Your answer should be very brief. -3.71. In the year 2009, what is the difference between the Cost (as % of GNI) in Minerals and Cost (as % of GNI) in Energy?
Your answer should be very brief. -2.25. In the year 2009, what is the difference between the Cost (as % of GNI) of Minerals and Cost (as % of GNI) of Water?
Give a very brief answer. -3.37. In the year 2009, what is the difference between the Cost (as % of GNI) in Energy and Cost (as % of GNI) in Water?
Give a very brief answer. -1.13. In the year 2010, what is the difference between the Cost (as % of GNI) in Coal and Cost (as % of GNI) in Minerals?
Ensure brevity in your answer.  -0.78. In the year 2010, what is the difference between the Cost (as % of GNI) in Coal and Cost (as % of GNI) in Energy?
Provide a succinct answer. -2.75. In the year 2010, what is the difference between the Cost (as % of GNI) in Coal and Cost (as % of GNI) in Water?
Your answer should be compact. -4.4. In the year 2010, what is the difference between the Cost (as % of GNI) in Minerals and Cost (as % of GNI) in Energy?
Offer a terse response. -1.97. In the year 2010, what is the difference between the Cost (as % of GNI) of Minerals and Cost (as % of GNI) of Water?
Your answer should be very brief. -3.61. In the year 2010, what is the difference between the Cost (as % of GNI) of Energy and Cost (as % of GNI) of Water?
Offer a very short reply. -1.64. In the year 2011, what is the difference between the Cost (as % of GNI) in Coal and Cost (as % of GNI) in Minerals?
Give a very brief answer. -0.97. In the year 2011, what is the difference between the Cost (as % of GNI) of Coal and Cost (as % of GNI) of Energy?
Your answer should be very brief. -3.32. In the year 2011, what is the difference between the Cost (as % of GNI) in Coal and Cost (as % of GNI) in Water?
Your answer should be compact. -4.99. In the year 2011, what is the difference between the Cost (as % of GNI) in Minerals and Cost (as % of GNI) in Energy?
Provide a succinct answer. -2.35. In the year 2011, what is the difference between the Cost (as % of GNI) of Minerals and Cost (as % of GNI) of Water?
Your answer should be compact. -4.02. In the year 2011, what is the difference between the Cost (as % of GNI) of Energy and Cost (as % of GNI) of Water?
Provide a short and direct response. -1.67. In the year 2012, what is the difference between the Cost (as % of GNI) of Coal and Cost (as % of GNI) of Minerals?
Your answer should be very brief. -0.83. In the year 2012, what is the difference between the Cost (as % of GNI) of Coal and Cost (as % of GNI) of Energy?
Your answer should be compact. -3.21. In the year 2012, what is the difference between the Cost (as % of GNI) in Coal and Cost (as % of GNI) in Water?
Offer a terse response. -4.82. In the year 2012, what is the difference between the Cost (as % of GNI) of Minerals and Cost (as % of GNI) of Energy?
Provide a succinct answer. -2.38. In the year 2012, what is the difference between the Cost (as % of GNI) in Minerals and Cost (as % of GNI) in Water?
Your answer should be very brief. -3.99. In the year 2012, what is the difference between the Cost (as % of GNI) of Energy and Cost (as % of GNI) of Water?
Offer a very short reply. -1.61. In the year 2013, what is the difference between the Cost (as % of GNI) of Coal and Cost (as % of GNI) of Minerals?
Provide a short and direct response. -0.71. In the year 2013, what is the difference between the Cost (as % of GNI) in Coal and Cost (as % of GNI) in Energy?
Offer a terse response. -2.99. In the year 2013, what is the difference between the Cost (as % of GNI) in Coal and Cost (as % of GNI) in Water?
Provide a succinct answer. -4.48. In the year 2013, what is the difference between the Cost (as % of GNI) of Minerals and Cost (as % of GNI) of Energy?
Provide a short and direct response. -2.28. In the year 2013, what is the difference between the Cost (as % of GNI) of Minerals and Cost (as % of GNI) of Water?
Provide a succinct answer. -3.77. In the year 2013, what is the difference between the Cost (as % of GNI) of Energy and Cost (as % of GNI) of Water?
Offer a terse response. -1.49. What is the ratio of the Cost (as % of GNI) in Coal in 2007 to that in 2008?
Provide a short and direct response. 1.07. What is the ratio of the Cost (as % of GNI) in Minerals in 2007 to that in 2008?
Ensure brevity in your answer.  1.08. What is the ratio of the Cost (as % of GNI) of Energy in 2007 to that in 2008?
Offer a terse response. 0.85. What is the ratio of the Cost (as % of GNI) of Water in 2007 to that in 2008?
Offer a terse response. 0.9. What is the ratio of the Cost (as % of GNI) in Minerals in 2007 to that in 2009?
Provide a succinct answer. 1.88. What is the ratio of the Cost (as % of GNI) in Energy in 2007 to that in 2009?
Your answer should be very brief. 1.44. What is the ratio of the Cost (as % of GNI) of Water in 2007 to that in 2009?
Your answer should be very brief. 1.46. What is the ratio of the Cost (as % of GNI) of Coal in 2007 to that in 2010?
Your response must be concise. 1.17. What is the ratio of the Cost (as % of GNI) in Minerals in 2007 to that in 2010?
Your answer should be compact. 1.16. What is the ratio of the Cost (as % of GNI) in Energy in 2007 to that in 2010?
Keep it short and to the point. 1.38. What is the ratio of the Cost (as % of GNI) of Water in 2007 to that in 2010?
Make the answer very short. 1.26. What is the ratio of the Cost (as % of GNI) in Coal in 2007 to that in 2011?
Offer a terse response. 1.28. What is the ratio of the Cost (as % of GNI) in Minerals in 2007 to that in 2011?
Keep it short and to the point. 1.01. What is the ratio of the Cost (as % of GNI) of Energy in 2007 to that in 2011?
Offer a terse response. 1.17. What is the ratio of the Cost (as % of GNI) in Water in 2007 to that in 2011?
Give a very brief answer. 1.12. What is the ratio of the Cost (as % of GNI) in Coal in 2007 to that in 2012?
Offer a terse response. 1.2. What is the ratio of the Cost (as % of GNI) of Minerals in 2007 to that in 2012?
Ensure brevity in your answer.  1.12. What is the ratio of the Cost (as % of GNI) of Energy in 2007 to that in 2012?
Ensure brevity in your answer.  1.2. What is the ratio of the Cost (as % of GNI) in Water in 2007 to that in 2012?
Provide a succinct answer. 1.16. What is the ratio of the Cost (as % of GNI) in Coal in 2007 to that in 2013?
Keep it short and to the point. 1.16. What is the ratio of the Cost (as % of GNI) in Minerals in 2007 to that in 2013?
Provide a short and direct response. 1.24. What is the ratio of the Cost (as % of GNI) in Energy in 2007 to that in 2013?
Keep it short and to the point. 1.28. What is the ratio of the Cost (as % of GNI) of Water in 2007 to that in 2013?
Make the answer very short. 1.24. What is the ratio of the Cost (as % of GNI) in Coal in 2008 to that in 2009?
Your response must be concise. 0.94. What is the ratio of the Cost (as % of GNI) of Minerals in 2008 to that in 2009?
Offer a terse response. 1.73. What is the ratio of the Cost (as % of GNI) in Energy in 2008 to that in 2009?
Offer a terse response. 1.7. What is the ratio of the Cost (as % of GNI) of Water in 2008 to that in 2009?
Ensure brevity in your answer.  1.62. What is the ratio of the Cost (as % of GNI) of Coal in 2008 to that in 2010?
Give a very brief answer. 1.1. What is the ratio of the Cost (as % of GNI) of Minerals in 2008 to that in 2010?
Your response must be concise. 1.07. What is the ratio of the Cost (as % of GNI) in Energy in 2008 to that in 2010?
Your answer should be compact. 1.63. What is the ratio of the Cost (as % of GNI) of Water in 2008 to that in 2010?
Your answer should be compact. 1.39. What is the ratio of the Cost (as % of GNI) of Coal in 2008 to that in 2011?
Give a very brief answer. 1.19. What is the ratio of the Cost (as % of GNI) in Minerals in 2008 to that in 2011?
Your answer should be very brief. 0.93. What is the ratio of the Cost (as % of GNI) in Energy in 2008 to that in 2011?
Offer a very short reply. 1.38. What is the ratio of the Cost (as % of GNI) of Water in 2008 to that in 2011?
Your answer should be very brief. 1.24. What is the ratio of the Cost (as % of GNI) in Coal in 2008 to that in 2012?
Your response must be concise. 1.12. What is the ratio of the Cost (as % of GNI) in Minerals in 2008 to that in 2012?
Offer a very short reply. 1.04. What is the ratio of the Cost (as % of GNI) in Energy in 2008 to that in 2012?
Ensure brevity in your answer.  1.42. What is the ratio of the Cost (as % of GNI) in Water in 2008 to that in 2012?
Offer a terse response. 1.28. What is the ratio of the Cost (as % of GNI) in Coal in 2008 to that in 2013?
Provide a short and direct response. 1.08. What is the ratio of the Cost (as % of GNI) of Minerals in 2008 to that in 2013?
Your answer should be very brief. 1.15. What is the ratio of the Cost (as % of GNI) in Energy in 2008 to that in 2013?
Keep it short and to the point. 1.51. What is the ratio of the Cost (as % of GNI) in Water in 2008 to that in 2013?
Your response must be concise. 1.37. What is the ratio of the Cost (as % of GNI) of Coal in 2009 to that in 2010?
Make the answer very short. 1.17. What is the ratio of the Cost (as % of GNI) in Minerals in 2009 to that in 2010?
Offer a very short reply. 0.62. What is the ratio of the Cost (as % of GNI) in Energy in 2009 to that in 2010?
Keep it short and to the point. 0.96. What is the ratio of the Cost (as % of GNI) of Water in 2009 to that in 2010?
Your response must be concise. 0.86. What is the ratio of the Cost (as % of GNI) of Coal in 2009 to that in 2011?
Make the answer very short. 1.27. What is the ratio of the Cost (as % of GNI) in Minerals in 2009 to that in 2011?
Give a very brief answer. 0.54. What is the ratio of the Cost (as % of GNI) in Energy in 2009 to that in 2011?
Make the answer very short. 0.81. What is the ratio of the Cost (as % of GNI) of Water in 2009 to that in 2011?
Your answer should be compact. 0.77. What is the ratio of the Cost (as % of GNI) of Coal in 2009 to that in 2012?
Your answer should be compact. 1.19. What is the ratio of the Cost (as % of GNI) of Minerals in 2009 to that in 2012?
Provide a short and direct response. 0.6. What is the ratio of the Cost (as % of GNI) in Energy in 2009 to that in 2012?
Give a very brief answer. 0.83. What is the ratio of the Cost (as % of GNI) in Water in 2009 to that in 2012?
Your answer should be compact. 0.79. What is the ratio of the Cost (as % of GNI) in Coal in 2009 to that in 2013?
Ensure brevity in your answer.  1.15. What is the ratio of the Cost (as % of GNI) in Minerals in 2009 to that in 2013?
Ensure brevity in your answer.  0.66. What is the ratio of the Cost (as % of GNI) in Energy in 2009 to that in 2013?
Provide a short and direct response. 0.89. What is the ratio of the Cost (as % of GNI) of Water in 2009 to that in 2013?
Your answer should be very brief. 0.85. What is the ratio of the Cost (as % of GNI) in Coal in 2010 to that in 2011?
Your response must be concise. 1.09. What is the ratio of the Cost (as % of GNI) of Minerals in 2010 to that in 2011?
Keep it short and to the point. 0.87. What is the ratio of the Cost (as % of GNI) in Energy in 2010 to that in 2011?
Make the answer very short. 0.85. What is the ratio of the Cost (as % of GNI) of Water in 2010 to that in 2011?
Your answer should be compact. 0.89. What is the ratio of the Cost (as % of GNI) of Coal in 2010 to that in 2012?
Provide a succinct answer. 1.02. What is the ratio of the Cost (as % of GNI) in Minerals in 2010 to that in 2012?
Offer a terse response. 0.96. What is the ratio of the Cost (as % of GNI) of Energy in 2010 to that in 2012?
Your answer should be compact. 0.87. What is the ratio of the Cost (as % of GNI) in Water in 2010 to that in 2012?
Ensure brevity in your answer.  0.92. What is the ratio of the Cost (as % of GNI) in Minerals in 2010 to that in 2013?
Make the answer very short. 1.07. What is the ratio of the Cost (as % of GNI) in Energy in 2010 to that in 2013?
Offer a very short reply. 0.93. What is the ratio of the Cost (as % of GNI) of Water in 2010 to that in 2013?
Give a very brief answer. 0.98. What is the ratio of the Cost (as % of GNI) in Coal in 2011 to that in 2012?
Your answer should be very brief. 0.94. What is the ratio of the Cost (as % of GNI) of Minerals in 2011 to that in 2012?
Keep it short and to the point. 1.11. What is the ratio of the Cost (as % of GNI) in Energy in 2011 to that in 2012?
Give a very brief answer. 1.03. What is the ratio of the Cost (as % of GNI) of Water in 2011 to that in 2012?
Ensure brevity in your answer.  1.03. What is the ratio of the Cost (as % of GNI) of Coal in 2011 to that in 2013?
Provide a succinct answer. 0.91. What is the ratio of the Cost (as % of GNI) of Minerals in 2011 to that in 2013?
Ensure brevity in your answer.  1.23. What is the ratio of the Cost (as % of GNI) in Energy in 2011 to that in 2013?
Ensure brevity in your answer.  1.09. What is the ratio of the Cost (as % of GNI) in Water in 2011 to that in 2013?
Give a very brief answer. 1.1. What is the ratio of the Cost (as % of GNI) of Coal in 2012 to that in 2013?
Your answer should be very brief. 0.97. What is the ratio of the Cost (as % of GNI) of Minerals in 2012 to that in 2013?
Keep it short and to the point. 1.11. What is the ratio of the Cost (as % of GNI) of Energy in 2012 to that in 2013?
Offer a terse response. 1.06. What is the ratio of the Cost (as % of GNI) in Water in 2012 to that in 2013?
Provide a short and direct response. 1.07. What is the difference between the highest and the second highest Cost (as % of GNI) of Coal?
Provide a succinct answer. 0. What is the difference between the highest and the second highest Cost (as % of GNI) in Minerals?
Provide a short and direct response. 0.01. What is the difference between the highest and the second highest Cost (as % of GNI) of Energy?
Provide a succinct answer. 0.75. What is the difference between the highest and the second highest Cost (as % of GNI) in Water?
Keep it short and to the point. 0.63. What is the difference between the highest and the lowest Cost (as % of GNI) of Coal?
Make the answer very short. 0.07. What is the difference between the highest and the lowest Cost (as % of GNI) of Minerals?
Ensure brevity in your answer.  0.58. What is the difference between the highest and the lowest Cost (as % of GNI) of Energy?
Make the answer very short. 2.02. What is the difference between the highest and the lowest Cost (as % of GNI) of Water?
Give a very brief answer. 2.48. 